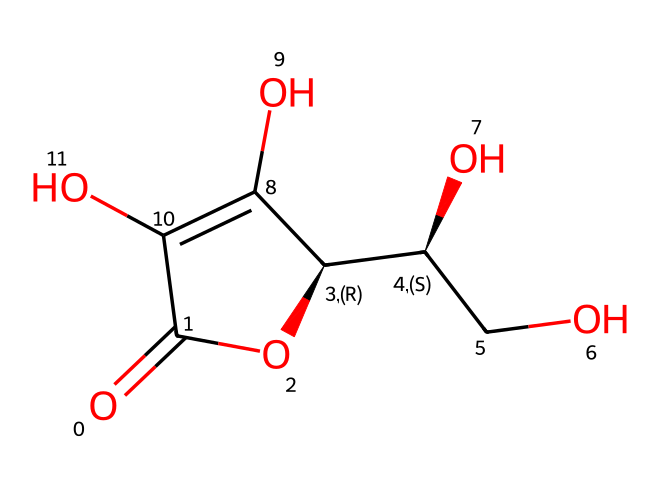What is the molecular formula of ascorbic acid? To determine the molecular formula, we can count the number of each type of atom present in the chemical structure derived from the SMILES notation. From the SMILES, we identify the atoms: there are 6 carbon (C) atoms, 8 hydrogen (H) atoms, and 6 oxygen (O) atoms. Therefore, the molecular formula is C6H8O6.
Answer: C6H8O6 How many chiral centers are present in ascorbic acid? Chiral centers are carbon atoms bonded to four different substituents. By examining the structure represented in the SMILES, we can identify that there are two carbon atoms connected to four different groups (one of these carbons also connects to a hydroxyl group, a hydrogen atom, and a carbon atom). Therefore, ascorbic acid has two chiral centers.
Answer: 2 What functional groups are present in ascorbic acid? Functional groups are specific groups of atoms within molecules that are responsible for characteristic chemical reactions. Observing the structure from the SMILES, we find hydroxyl (-OH) groups and a carbonyl (C=O) group, indicating the presence of alcohol and aldehyde functional groups.
Answer: alcohol, aldehyde What is the primary role of ascorbic acid in preserving fruits? The primary role of ascorbic acid in preserving fruits is to act as an antioxidant. It helps prevent the oxidation process that leads to browning in fruits by donating electrons to free radicals and inhibiting the enzymatic reactions that cause the oxidation of phenolic compounds.
Answer: antioxidant How does the structure of ascorbic acid contribute to its solubility in water? The presence of multiple hydroxyl (-OH) groups in the structure of ascorbic acid increases its polarity, making it hydrophilic. This allows ascorbic acid to interact with water molecules, leading to its high solubility. The numerous hydroxy groups from the structure make it more readily soluble in aqueous environments.
Answer: high solubility Which part of the ascorbic acid structure is most reactive toward oxidation? The most reactive part of ascorbic acid toward oxidation is the carbonyl group (C=O), as it can easily undergo oxidation reactions. This carbonyl group is involved in redox reactions and is key to ascorbic acid's antioxidant properties.
Answer: carbonyl group 